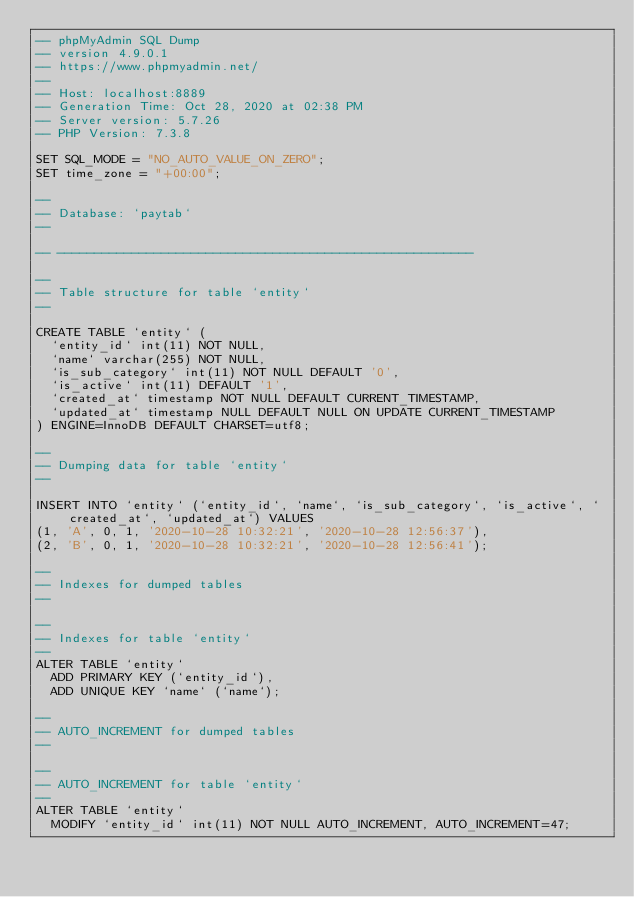Convert code to text. <code><loc_0><loc_0><loc_500><loc_500><_SQL_>-- phpMyAdmin SQL Dump
-- version 4.9.0.1
-- https://www.phpmyadmin.net/
--
-- Host: localhost:8889
-- Generation Time: Oct 28, 2020 at 02:38 PM
-- Server version: 5.7.26
-- PHP Version: 7.3.8

SET SQL_MODE = "NO_AUTO_VALUE_ON_ZERO";
SET time_zone = "+00:00";

--
-- Database: `paytab`
--

-- --------------------------------------------------------

--
-- Table structure for table `entity`
--

CREATE TABLE `entity` (
  `entity_id` int(11) NOT NULL,
  `name` varchar(255) NOT NULL,
  `is_sub_category` int(11) NOT NULL DEFAULT '0',
  `is_active` int(11) DEFAULT '1',
  `created_at` timestamp NOT NULL DEFAULT CURRENT_TIMESTAMP,
  `updated_at` timestamp NULL DEFAULT NULL ON UPDATE CURRENT_TIMESTAMP
) ENGINE=InnoDB DEFAULT CHARSET=utf8;

--
-- Dumping data for table `entity`
--

INSERT INTO `entity` (`entity_id`, `name`, `is_sub_category`, `is_active`, `created_at`, `updated_at`) VALUES
(1, 'A', 0, 1, '2020-10-28 10:32:21', '2020-10-28 12:56:37'),
(2, 'B', 0, 1, '2020-10-28 10:32:21', '2020-10-28 12:56:41');

--
-- Indexes for dumped tables
--

--
-- Indexes for table `entity`
--
ALTER TABLE `entity`
  ADD PRIMARY KEY (`entity_id`),
  ADD UNIQUE KEY `name` (`name`);

--
-- AUTO_INCREMENT for dumped tables
--

--
-- AUTO_INCREMENT for table `entity`
--
ALTER TABLE `entity`
  MODIFY `entity_id` int(11) NOT NULL AUTO_INCREMENT, AUTO_INCREMENT=47;
</code> 